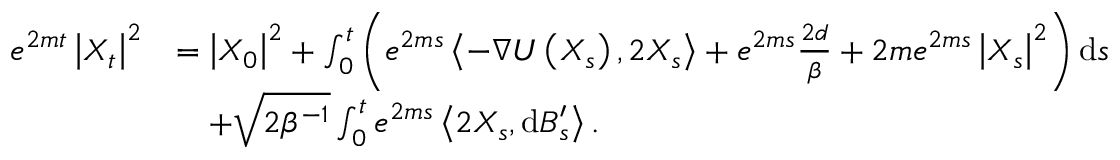Convert formula to latex. <formula><loc_0><loc_0><loc_500><loc_500>\begin{array} { r l } { e ^ { 2 m t } \left | X _ { t } \right | ^ { 2 } } & { = \left | X _ { 0 } \right | ^ { 2 } + \int _ { 0 } ^ { t } \left ( e ^ { 2 m s } \left \langle - \nabla U \left ( X _ { s } \right ) , 2 X _ { s } \right \rangle + e ^ { 2 m s } \frac { 2 d } { \beta } + 2 m e ^ { 2 m s } \left | X _ { s } \right | ^ { 2 } \right ) d s } \\ & { \quad + \sqrt { 2 \beta ^ { - 1 } } \int _ { 0 } ^ { t } e ^ { 2 m s } \left \langle 2 X _ { s } , d B _ { s } ^ { \prime } \right \rangle . } \end{array}</formula> 